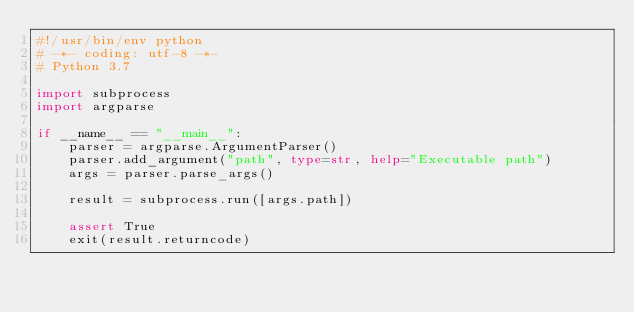Convert code to text. <code><loc_0><loc_0><loc_500><loc_500><_Python_>#!/usr/bin/env python
# -*- coding: utf-8 -*-
# Python 3.7

import subprocess
import argparse

if __name__ == "__main__":
    parser = argparse.ArgumentParser()
    parser.add_argument("path", type=str, help="Executable path")
    args = parser.parse_args()

    result = subprocess.run([args.path])

    assert True
    exit(result.returncode)
</code> 